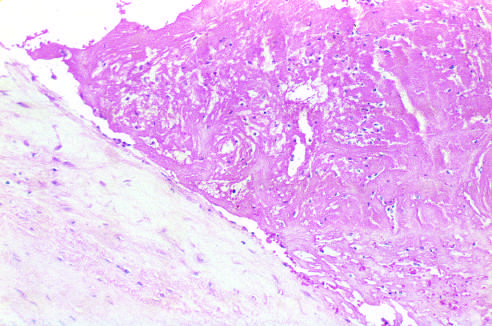what is the thrombus loosely attached to?
Answer the question using a single word or phrase. The cusp 